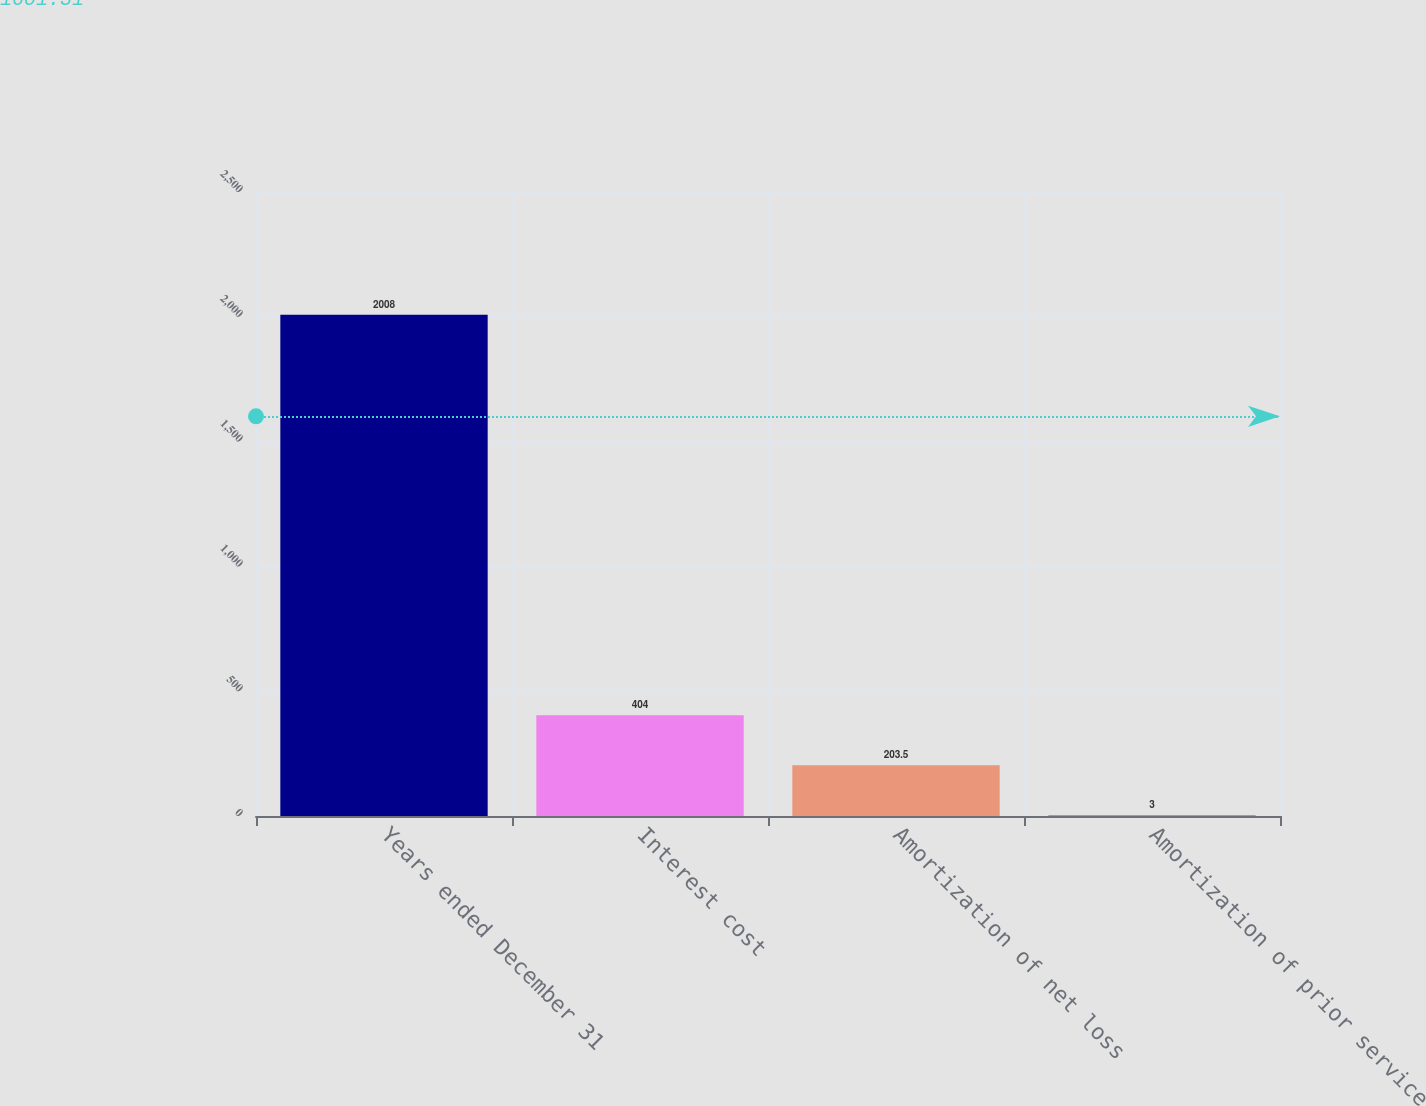Convert chart. <chart><loc_0><loc_0><loc_500><loc_500><bar_chart><fcel>Years ended December 31<fcel>Interest cost<fcel>Amortization of net loss<fcel>Amortization of prior service<nl><fcel>2008<fcel>404<fcel>203.5<fcel>3<nl></chart> 